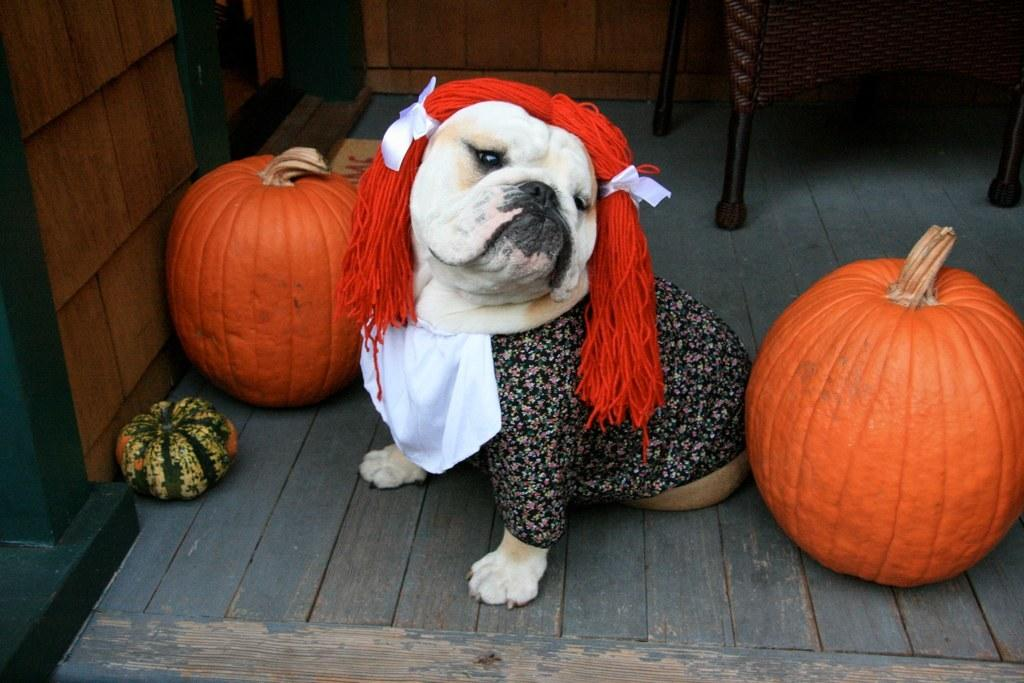What animal can be seen in the image? There is a dog in the image. Where is the dog located in the image? The dog is sitting on the floor. What is the dog wearing in the image? The dog is wearing clothes. What objects are placed beside the dog? There are pumpkins placed beside the dog. What type of walls are visible in the image? There are wooden walls visible in the image. What piece of furniture can be seen in the image? There is a chair in the image. What type of relation does the dog have with the person in the image? There is no person visible in the image, so it is not possible to determine the dog's relation to anyone. 